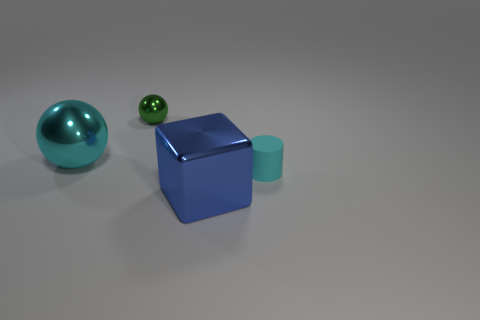Add 3 tiny green balls. How many objects exist? 7 Subtract all cylinders. How many objects are left? 3 Subtract all small matte cylinders. Subtract all metallic spheres. How many objects are left? 1 Add 3 tiny rubber cylinders. How many tiny rubber cylinders are left? 4 Add 4 purple metal cylinders. How many purple metal cylinders exist? 4 Subtract 0 gray cylinders. How many objects are left? 4 